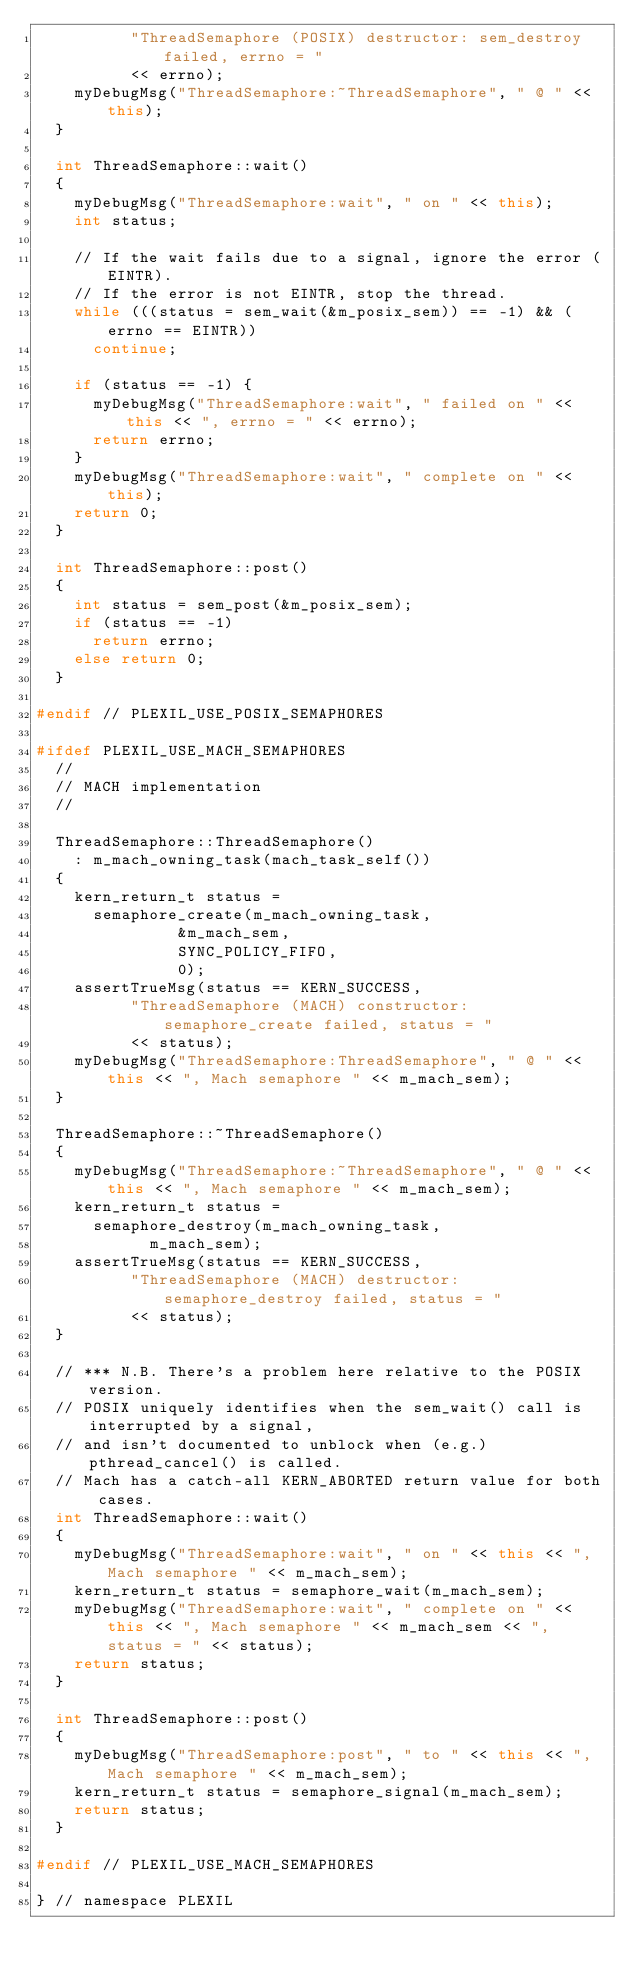Convert code to text. <code><loc_0><loc_0><loc_500><loc_500><_C++_>		  "ThreadSemaphore (POSIX) destructor: sem_destroy failed, errno = "
		  << errno);
	myDebugMsg("ThreadSemaphore:~ThreadSemaphore", " @ " << this);
  }

  int ThreadSemaphore::wait()
  {
	myDebugMsg("ThreadSemaphore:wait", " on " << this);
    int status;

    // If the wait fails due to a signal, ignore the error (EINTR).
    // If the error is not EINTR, stop the thread.
    while (((status = sem_wait(&m_posix_sem)) == -1) && (errno == EINTR))
      continue;
    
    if (status == -1) {
	  myDebugMsg("ThreadSemaphore:wait", " failed on " << this << ", errno = " << errno);
      return errno;
	}
	myDebugMsg("ThreadSemaphore:wait", " complete on " << this);
    return 0;
  }

  int ThreadSemaphore::post()
  {
    int status = sem_post(&m_posix_sem);
    if (status == -1)
      return errno;
    else return 0;
  }

#endif // PLEXIL_USE_POSIX_SEMAPHORES

#ifdef PLEXIL_USE_MACH_SEMAPHORES
  //
  // MACH implementation
  //

  ThreadSemaphore::ThreadSemaphore()
	: m_mach_owning_task(mach_task_self())
  {
    kern_return_t status = 
      semaphore_create(m_mach_owning_task,
		       &m_mach_sem,
		       SYNC_POLICY_FIFO,
		       0);
    assertTrueMsg(status == KERN_SUCCESS,
		  "ThreadSemaphore (MACH) constructor: semaphore_create failed, status = "
		  << status);
	myDebugMsg("ThreadSemaphore:ThreadSemaphore", " @ " << this << ", Mach semaphore " << m_mach_sem);
  }

  ThreadSemaphore::~ThreadSemaphore()
  {
	myDebugMsg("ThreadSemaphore:~ThreadSemaphore", " @ " << this << ", Mach semaphore " << m_mach_sem);
    kern_return_t status = 
      semaphore_destroy(m_mach_owning_task,
			m_mach_sem);
    assertTrueMsg(status == KERN_SUCCESS,
		  "ThreadSemaphore (MACH) destructor: semaphore_destroy failed, status = "
		  << status);
  }

  // *** N.B. There's a problem here relative to the POSIX version.
  // POSIX uniquely identifies when the sem_wait() call is interrupted by a signal, 
  // and isn't documented to unblock when (e.g.) pthread_cancel() is called.
  // Mach has a catch-all KERN_ABORTED return value for both cases.
  int ThreadSemaphore::wait()
  {
	myDebugMsg("ThreadSemaphore:wait", " on " << this << ", Mach semaphore " << m_mach_sem);
    kern_return_t status = semaphore_wait(m_mach_sem);
	myDebugMsg("ThreadSemaphore:wait", " complete on " << this << ", Mach semaphore " << m_mach_sem << ", status = " << status);
    return status;
  }

  int ThreadSemaphore::post()
  {
	myDebugMsg("ThreadSemaphore:post", " to " << this << ", Mach semaphore " << m_mach_sem);
    kern_return_t status = semaphore_signal(m_mach_sem);
    return status;
  }

#endif // PLEXIL_USE_MACH_SEMAPHORES

} // namespace PLEXIL
</code> 